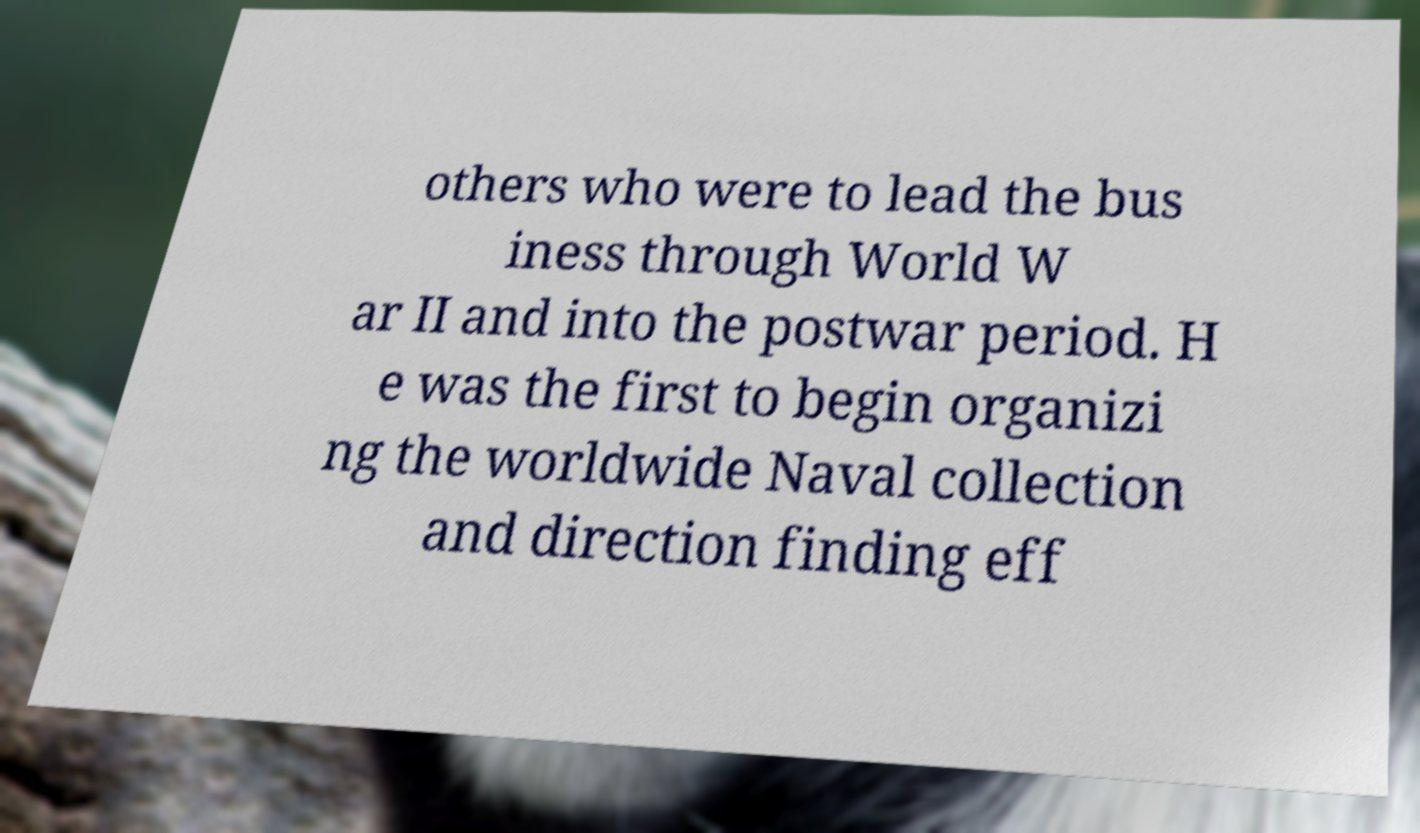What messages or text are displayed in this image? I need them in a readable, typed format. others who were to lead the bus iness through World W ar II and into the postwar period. H e was the first to begin organizi ng the worldwide Naval collection and direction finding eff 